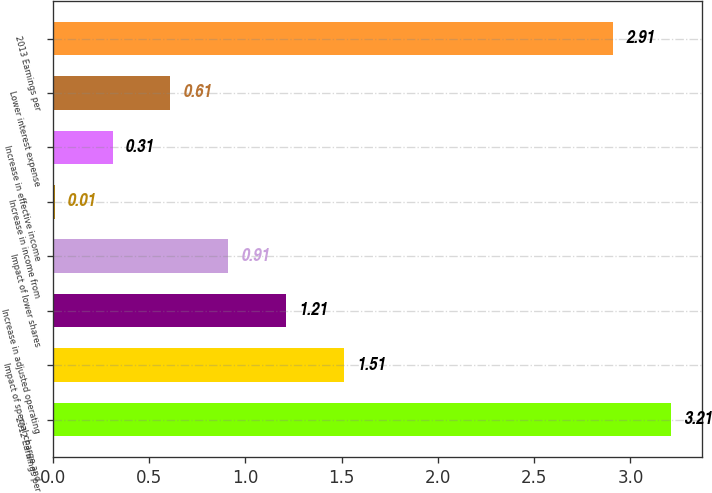<chart> <loc_0><loc_0><loc_500><loc_500><bar_chart><fcel>2012 Earnings per<fcel>Impact of special charge and<fcel>Increase in adjusted operating<fcel>Impact of lower shares<fcel>Increase in income from<fcel>Increase in effective income<fcel>Lower interest expense<fcel>2013 Earnings per<nl><fcel>3.21<fcel>1.51<fcel>1.21<fcel>0.91<fcel>0.01<fcel>0.31<fcel>0.61<fcel>2.91<nl></chart> 